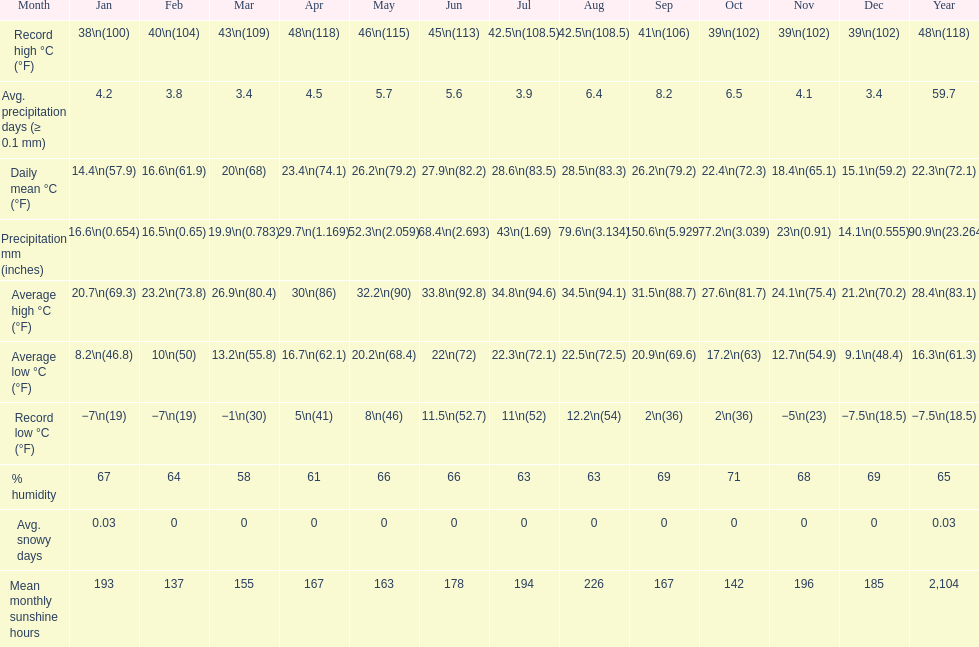Does december or january have more snow days? January. 